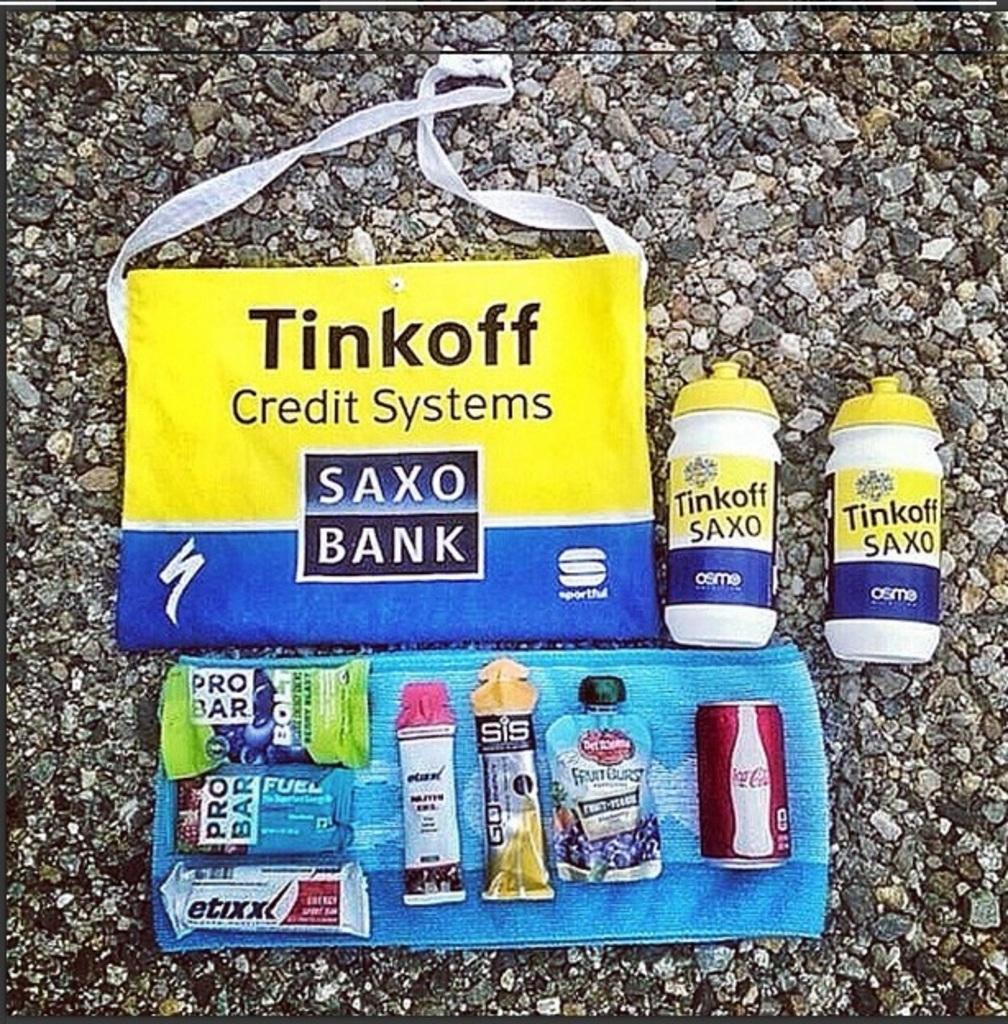Did a company put together those supplies?
Offer a terse response. Yes. What is the name of the systems?
Offer a very short reply. Tinkoff. 